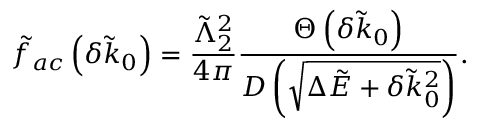Convert formula to latex. <formula><loc_0><loc_0><loc_500><loc_500>\tilde { f } _ { a c } \left ( \delta \tilde { k } _ { 0 } \right ) = \frac { \tilde { \Lambda } _ { 2 } ^ { 2 } } { 4 \pi } \frac { \Theta \left ( \delta \tilde { k } _ { 0 } \right ) } { D \left ( \sqrt { \Delta \tilde { E } + \delta \tilde { k } _ { 0 } ^ { 2 } } \right ) } .</formula> 